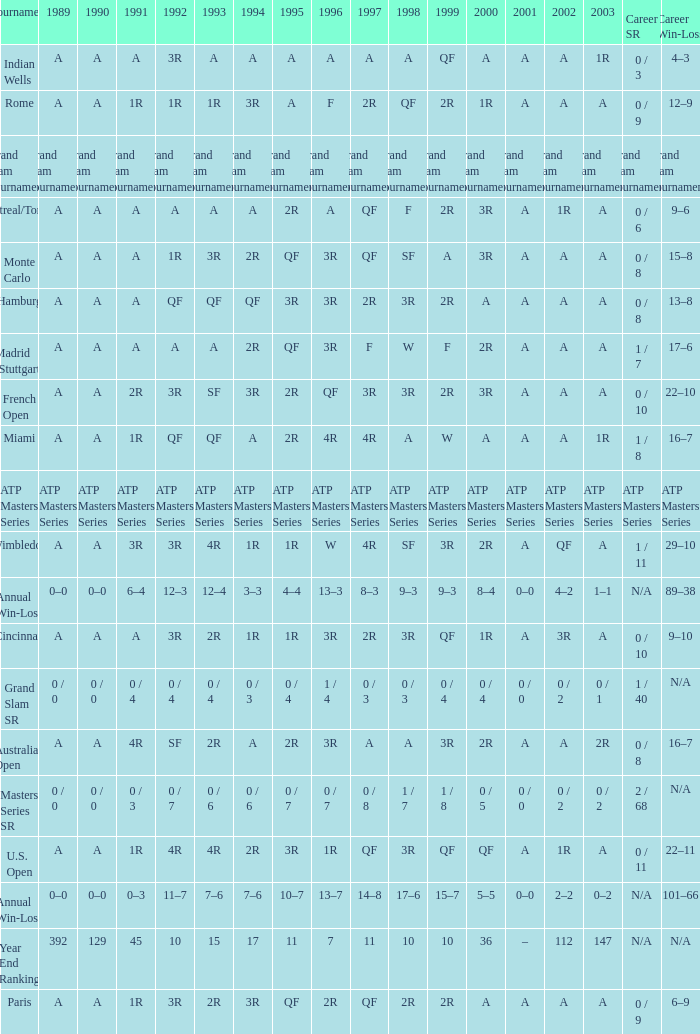What was the career SR with a value of A in 1980 and F in 1997? 1 / 7. 